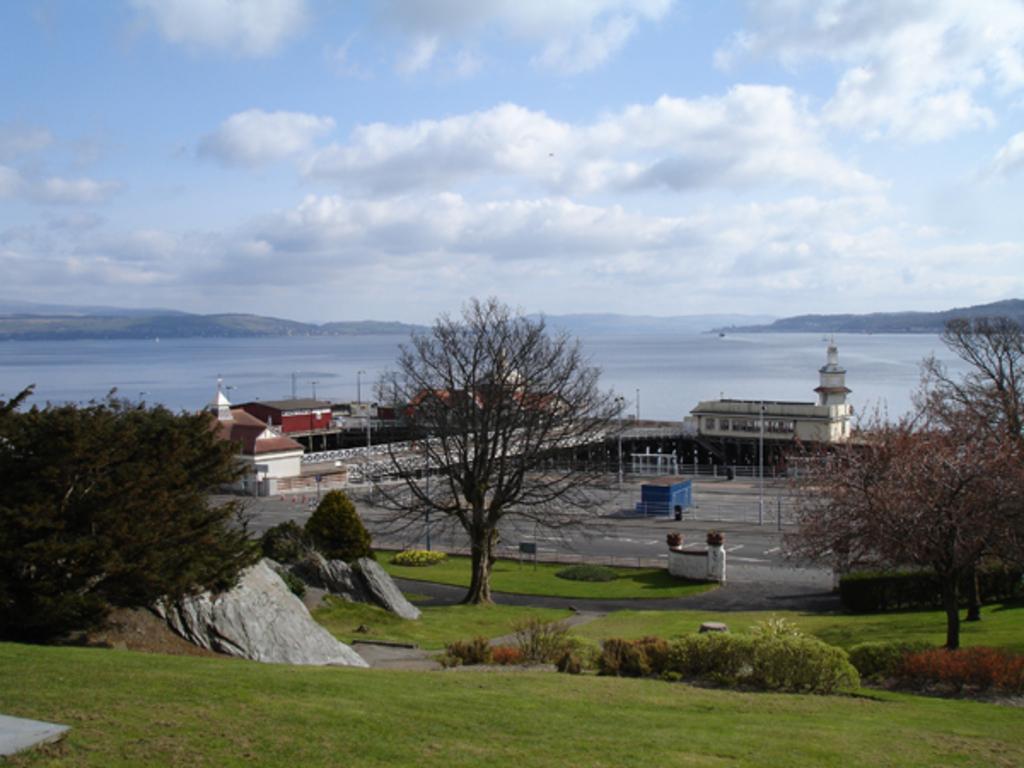Describe this image in one or two sentences. In this image I can see the ocean in the middle,at the top I can see the sky , in front of ocean I can see building and trees and bushes and stones visible in the middle I can see the hill 